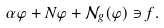<formula> <loc_0><loc_0><loc_500><loc_500>\alpha \varphi + N \varphi + \mathcal { N } _ { g } ( \varphi ) \ni f .</formula> 